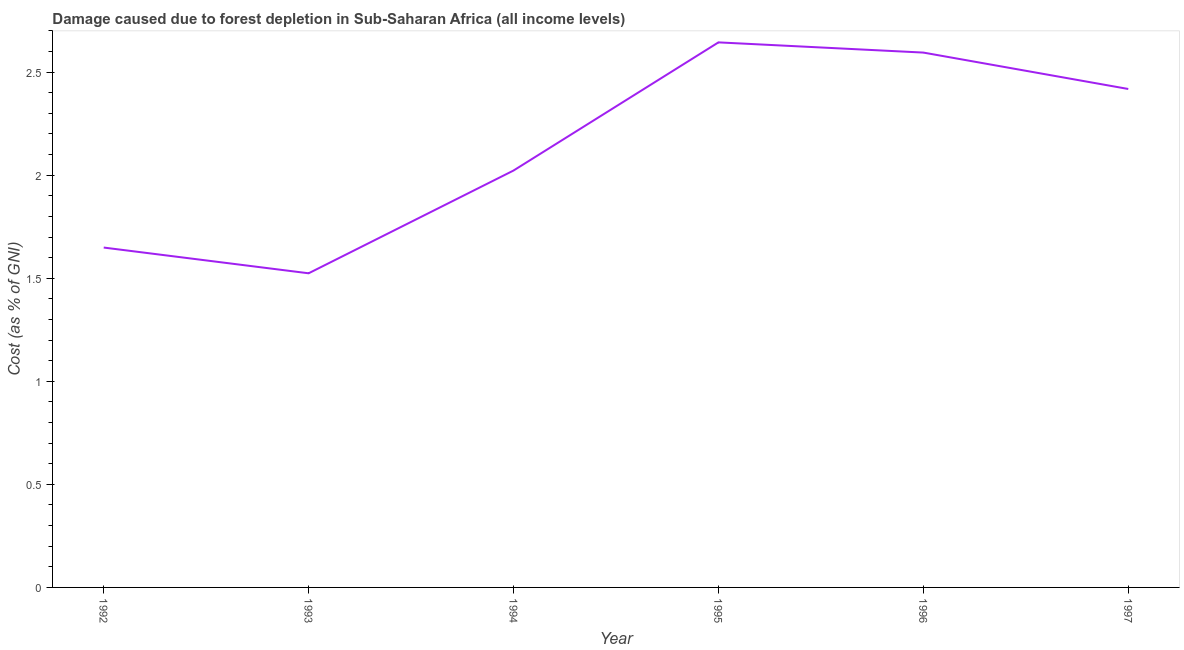What is the damage caused due to forest depletion in 1994?
Your answer should be very brief. 2.02. Across all years, what is the maximum damage caused due to forest depletion?
Provide a succinct answer. 2.64. Across all years, what is the minimum damage caused due to forest depletion?
Provide a short and direct response. 1.52. In which year was the damage caused due to forest depletion maximum?
Keep it short and to the point. 1995. In which year was the damage caused due to forest depletion minimum?
Your answer should be compact. 1993. What is the sum of the damage caused due to forest depletion?
Ensure brevity in your answer.  12.85. What is the difference between the damage caused due to forest depletion in 1993 and 1994?
Provide a succinct answer. -0.5. What is the average damage caused due to forest depletion per year?
Keep it short and to the point. 2.14. What is the median damage caused due to forest depletion?
Ensure brevity in your answer.  2.22. In how many years, is the damage caused due to forest depletion greater than 2.5 %?
Provide a succinct answer. 2. What is the ratio of the damage caused due to forest depletion in 1994 to that in 1996?
Provide a succinct answer. 0.78. Is the damage caused due to forest depletion in 1992 less than that in 1995?
Your answer should be compact. Yes. Is the difference between the damage caused due to forest depletion in 1994 and 1997 greater than the difference between any two years?
Ensure brevity in your answer.  No. What is the difference between the highest and the second highest damage caused due to forest depletion?
Offer a very short reply. 0.05. What is the difference between the highest and the lowest damage caused due to forest depletion?
Make the answer very short. 1.12. Does the damage caused due to forest depletion monotonically increase over the years?
Make the answer very short. No. How many years are there in the graph?
Provide a short and direct response. 6. What is the difference between two consecutive major ticks on the Y-axis?
Your answer should be very brief. 0.5. Are the values on the major ticks of Y-axis written in scientific E-notation?
Your response must be concise. No. Does the graph contain any zero values?
Ensure brevity in your answer.  No. Does the graph contain grids?
Provide a short and direct response. No. What is the title of the graph?
Your answer should be compact. Damage caused due to forest depletion in Sub-Saharan Africa (all income levels). What is the label or title of the X-axis?
Give a very brief answer. Year. What is the label or title of the Y-axis?
Your answer should be compact. Cost (as % of GNI). What is the Cost (as % of GNI) of 1992?
Give a very brief answer. 1.65. What is the Cost (as % of GNI) of 1993?
Your answer should be compact. 1.52. What is the Cost (as % of GNI) of 1994?
Give a very brief answer. 2.02. What is the Cost (as % of GNI) of 1995?
Give a very brief answer. 2.64. What is the Cost (as % of GNI) in 1996?
Offer a terse response. 2.59. What is the Cost (as % of GNI) in 1997?
Make the answer very short. 2.42. What is the difference between the Cost (as % of GNI) in 1992 and 1993?
Your answer should be very brief. 0.12. What is the difference between the Cost (as % of GNI) in 1992 and 1994?
Provide a succinct answer. -0.37. What is the difference between the Cost (as % of GNI) in 1992 and 1995?
Your answer should be compact. -1. What is the difference between the Cost (as % of GNI) in 1992 and 1996?
Give a very brief answer. -0.95. What is the difference between the Cost (as % of GNI) in 1992 and 1997?
Provide a short and direct response. -0.77. What is the difference between the Cost (as % of GNI) in 1993 and 1994?
Keep it short and to the point. -0.5. What is the difference between the Cost (as % of GNI) in 1993 and 1995?
Provide a succinct answer. -1.12. What is the difference between the Cost (as % of GNI) in 1993 and 1996?
Provide a short and direct response. -1.07. What is the difference between the Cost (as % of GNI) in 1993 and 1997?
Your answer should be compact. -0.89. What is the difference between the Cost (as % of GNI) in 1994 and 1995?
Make the answer very short. -0.62. What is the difference between the Cost (as % of GNI) in 1994 and 1996?
Keep it short and to the point. -0.57. What is the difference between the Cost (as % of GNI) in 1994 and 1997?
Provide a short and direct response. -0.4. What is the difference between the Cost (as % of GNI) in 1995 and 1996?
Ensure brevity in your answer.  0.05. What is the difference between the Cost (as % of GNI) in 1995 and 1997?
Provide a succinct answer. 0.23. What is the difference between the Cost (as % of GNI) in 1996 and 1997?
Give a very brief answer. 0.18. What is the ratio of the Cost (as % of GNI) in 1992 to that in 1993?
Your response must be concise. 1.08. What is the ratio of the Cost (as % of GNI) in 1992 to that in 1994?
Give a very brief answer. 0.81. What is the ratio of the Cost (as % of GNI) in 1992 to that in 1995?
Offer a very short reply. 0.62. What is the ratio of the Cost (as % of GNI) in 1992 to that in 1996?
Offer a very short reply. 0.64. What is the ratio of the Cost (as % of GNI) in 1992 to that in 1997?
Offer a very short reply. 0.68. What is the ratio of the Cost (as % of GNI) in 1993 to that in 1994?
Offer a terse response. 0.75. What is the ratio of the Cost (as % of GNI) in 1993 to that in 1995?
Your answer should be very brief. 0.58. What is the ratio of the Cost (as % of GNI) in 1993 to that in 1996?
Your answer should be compact. 0.59. What is the ratio of the Cost (as % of GNI) in 1993 to that in 1997?
Keep it short and to the point. 0.63. What is the ratio of the Cost (as % of GNI) in 1994 to that in 1995?
Your answer should be very brief. 0.77. What is the ratio of the Cost (as % of GNI) in 1994 to that in 1996?
Keep it short and to the point. 0.78. What is the ratio of the Cost (as % of GNI) in 1994 to that in 1997?
Offer a terse response. 0.84. What is the ratio of the Cost (as % of GNI) in 1995 to that in 1997?
Provide a succinct answer. 1.09. What is the ratio of the Cost (as % of GNI) in 1996 to that in 1997?
Your response must be concise. 1.07. 